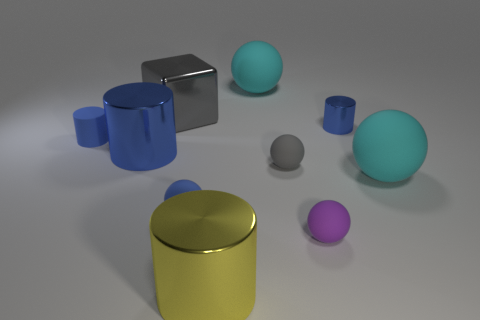There is a block; does it have the same color as the tiny rubber ball behind the blue matte sphere?
Give a very brief answer. Yes. There is a small blue matte thing on the left side of the large block; is its shape the same as the blue shiny thing that is in front of the small metallic cylinder?
Give a very brief answer. Yes. There is a small blue rubber cylinder; are there any tiny matte cylinders in front of it?
Your answer should be compact. No. There is a tiny matte thing that is the same shape as the small metallic thing; what color is it?
Make the answer very short. Blue. Are there any other things that are the same shape as the gray shiny object?
Provide a succinct answer. No. What material is the tiny blue thing on the right side of the small purple ball?
Your answer should be compact. Metal. There is a gray thing that is the same shape as the purple object; what is its size?
Offer a terse response. Small. How many blue cylinders have the same material as the block?
Your response must be concise. 2. How many balls have the same color as the rubber cylinder?
Keep it short and to the point. 1. What number of objects are either blue things right of the blue sphere or blue cylinders to the left of the small shiny cylinder?
Ensure brevity in your answer.  3. 